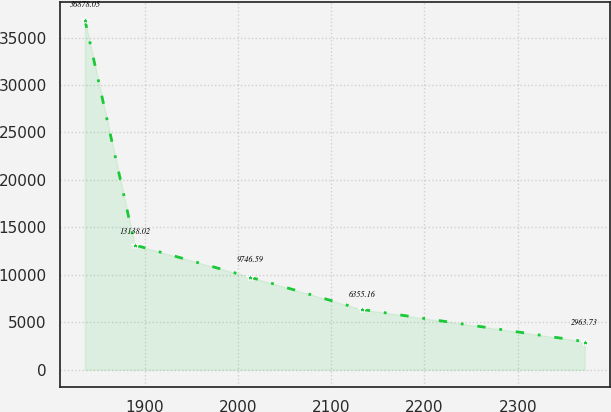Convert chart to OTSL. <chart><loc_0><loc_0><loc_500><loc_500><line_chart><ecel><fcel>Unnamed: 1<nl><fcel>1835.95<fcel>36878.1<nl><fcel>1889.55<fcel>13138<nl><fcel>2013.49<fcel>9746.59<nl><fcel>2132.78<fcel>6355.16<nl><fcel>2371.94<fcel>2963.73<nl></chart> 